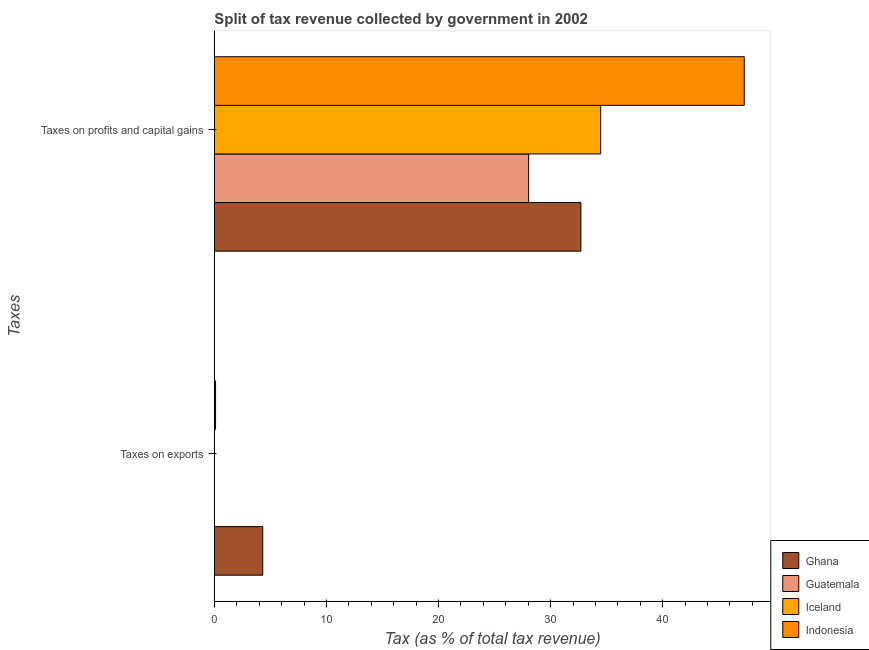How many different coloured bars are there?
Ensure brevity in your answer.  4. How many groups of bars are there?
Your answer should be very brief. 2. Are the number of bars per tick equal to the number of legend labels?
Provide a short and direct response. Yes. What is the label of the 2nd group of bars from the top?
Ensure brevity in your answer.  Taxes on exports. What is the percentage of revenue obtained from taxes on exports in Guatemala?
Give a very brief answer. 0.01. Across all countries, what is the maximum percentage of revenue obtained from taxes on profits and capital gains?
Your answer should be very brief. 47.28. Across all countries, what is the minimum percentage of revenue obtained from taxes on exports?
Your response must be concise. 0. In which country was the percentage of revenue obtained from taxes on exports maximum?
Offer a terse response. Ghana. In which country was the percentage of revenue obtained from taxes on profits and capital gains minimum?
Provide a succinct answer. Guatemala. What is the total percentage of revenue obtained from taxes on profits and capital gains in the graph?
Offer a very short reply. 142.5. What is the difference between the percentage of revenue obtained from taxes on exports in Ghana and that in Guatemala?
Ensure brevity in your answer.  4.31. What is the difference between the percentage of revenue obtained from taxes on profits and capital gains in Ghana and the percentage of revenue obtained from taxes on exports in Indonesia?
Provide a short and direct response. 32.6. What is the average percentage of revenue obtained from taxes on profits and capital gains per country?
Provide a succinct answer. 35.62. What is the difference between the percentage of revenue obtained from taxes on exports and percentage of revenue obtained from taxes on profits and capital gains in Guatemala?
Keep it short and to the point. -28.04. In how many countries, is the percentage of revenue obtained from taxes on profits and capital gains greater than 10 %?
Provide a short and direct response. 4. What is the ratio of the percentage of revenue obtained from taxes on exports in Indonesia to that in Guatemala?
Your response must be concise. 17.39. Is the percentage of revenue obtained from taxes on profits and capital gains in Iceland less than that in Guatemala?
Your response must be concise. No. In how many countries, is the percentage of revenue obtained from taxes on exports greater than the average percentage of revenue obtained from taxes on exports taken over all countries?
Provide a short and direct response. 1. What does the 2nd bar from the bottom in Taxes on exports represents?
Make the answer very short. Guatemala. How many bars are there?
Provide a succinct answer. 8. How many countries are there in the graph?
Your answer should be very brief. 4. Are the values on the major ticks of X-axis written in scientific E-notation?
Offer a terse response. No. How many legend labels are there?
Give a very brief answer. 4. How are the legend labels stacked?
Your answer should be compact. Vertical. What is the title of the graph?
Keep it short and to the point. Split of tax revenue collected by government in 2002. Does "China" appear as one of the legend labels in the graph?
Keep it short and to the point. No. What is the label or title of the X-axis?
Ensure brevity in your answer.  Tax (as % of total tax revenue). What is the label or title of the Y-axis?
Give a very brief answer. Taxes. What is the Tax (as % of total tax revenue) in Ghana in Taxes on exports?
Ensure brevity in your answer.  4.32. What is the Tax (as % of total tax revenue) of Guatemala in Taxes on exports?
Provide a succinct answer. 0.01. What is the Tax (as % of total tax revenue) in Iceland in Taxes on exports?
Ensure brevity in your answer.  0. What is the Tax (as % of total tax revenue) in Indonesia in Taxes on exports?
Your answer should be compact. 0.11. What is the Tax (as % of total tax revenue) of Ghana in Taxes on profits and capital gains?
Give a very brief answer. 32.7. What is the Tax (as % of total tax revenue) of Guatemala in Taxes on profits and capital gains?
Ensure brevity in your answer.  28.04. What is the Tax (as % of total tax revenue) in Iceland in Taxes on profits and capital gains?
Offer a very short reply. 34.47. What is the Tax (as % of total tax revenue) of Indonesia in Taxes on profits and capital gains?
Make the answer very short. 47.28. Across all Taxes, what is the maximum Tax (as % of total tax revenue) of Ghana?
Make the answer very short. 32.7. Across all Taxes, what is the maximum Tax (as % of total tax revenue) of Guatemala?
Your answer should be very brief. 28.04. Across all Taxes, what is the maximum Tax (as % of total tax revenue) of Iceland?
Provide a succinct answer. 34.47. Across all Taxes, what is the maximum Tax (as % of total tax revenue) in Indonesia?
Your answer should be compact. 47.28. Across all Taxes, what is the minimum Tax (as % of total tax revenue) in Ghana?
Provide a short and direct response. 4.32. Across all Taxes, what is the minimum Tax (as % of total tax revenue) of Guatemala?
Provide a short and direct response. 0.01. Across all Taxes, what is the minimum Tax (as % of total tax revenue) in Iceland?
Make the answer very short. 0. Across all Taxes, what is the minimum Tax (as % of total tax revenue) in Indonesia?
Offer a very short reply. 0.11. What is the total Tax (as % of total tax revenue) in Ghana in the graph?
Keep it short and to the point. 37.02. What is the total Tax (as % of total tax revenue) in Guatemala in the graph?
Offer a terse response. 28.05. What is the total Tax (as % of total tax revenue) in Iceland in the graph?
Provide a short and direct response. 34.47. What is the total Tax (as % of total tax revenue) in Indonesia in the graph?
Your answer should be very brief. 47.39. What is the difference between the Tax (as % of total tax revenue) of Ghana in Taxes on exports and that in Taxes on profits and capital gains?
Your response must be concise. -28.39. What is the difference between the Tax (as % of total tax revenue) of Guatemala in Taxes on exports and that in Taxes on profits and capital gains?
Give a very brief answer. -28.04. What is the difference between the Tax (as % of total tax revenue) in Iceland in Taxes on exports and that in Taxes on profits and capital gains?
Give a very brief answer. -34.47. What is the difference between the Tax (as % of total tax revenue) of Indonesia in Taxes on exports and that in Taxes on profits and capital gains?
Give a very brief answer. -47.17. What is the difference between the Tax (as % of total tax revenue) of Ghana in Taxes on exports and the Tax (as % of total tax revenue) of Guatemala in Taxes on profits and capital gains?
Offer a terse response. -23.73. What is the difference between the Tax (as % of total tax revenue) in Ghana in Taxes on exports and the Tax (as % of total tax revenue) in Iceland in Taxes on profits and capital gains?
Make the answer very short. -30.15. What is the difference between the Tax (as % of total tax revenue) of Ghana in Taxes on exports and the Tax (as % of total tax revenue) of Indonesia in Taxes on profits and capital gains?
Give a very brief answer. -42.96. What is the difference between the Tax (as % of total tax revenue) of Guatemala in Taxes on exports and the Tax (as % of total tax revenue) of Iceland in Taxes on profits and capital gains?
Ensure brevity in your answer.  -34.46. What is the difference between the Tax (as % of total tax revenue) of Guatemala in Taxes on exports and the Tax (as % of total tax revenue) of Indonesia in Taxes on profits and capital gains?
Ensure brevity in your answer.  -47.27. What is the difference between the Tax (as % of total tax revenue) in Iceland in Taxes on exports and the Tax (as % of total tax revenue) in Indonesia in Taxes on profits and capital gains?
Offer a very short reply. -47.28. What is the average Tax (as % of total tax revenue) in Ghana per Taxes?
Give a very brief answer. 18.51. What is the average Tax (as % of total tax revenue) of Guatemala per Taxes?
Keep it short and to the point. 14.02. What is the average Tax (as % of total tax revenue) of Iceland per Taxes?
Keep it short and to the point. 17.24. What is the average Tax (as % of total tax revenue) in Indonesia per Taxes?
Provide a succinct answer. 23.69. What is the difference between the Tax (as % of total tax revenue) of Ghana and Tax (as % of total tax revenue) of Guatemala in Taxes on exports?
Your answer should be compact. 4.31. What is the difference between the Tax (as % of total tax revenue) in Ghana and Tax (as % of total tax revenue) in Iceland in Taxes on exports?
Give a very brief answer. 4.32. What is the difference between the Tax (as % of total tax revenue) of Ghana and Tax (as % of total tax revenue) of Indonesia in Taxes on exports?
Ensure brevity in your answer.  4.21. What is the difference between the Tax (as % of total tax revenue) in Guatemala and Tax (as % of total tax revenue) in Iceland in Taxes on exports?
Offer a terse response. 0.01. What is the difference between the Tax (as % of total tax revenue) of Guatemala and Tax (as % of total tax revenue) of Indonesia in Taxes on exports?
Keep it short and to the point. -0.1. What is the difference between the Tax (as % of total tax revenue) of Iceland and Tax (as % of total tax revenue) of Indonesia in Taxes on exports?
Offer a very short reply. -0.11. What is the difference between the Tax (as % of total tax revenue) in Ghana and Tax (as % of total tax revenue) in Guatemala in Taxes on profits and capital gains?
Make the answer very short. 4.66. What is the difference between the Tax (as % of total tax revenue) of Ghana and Tax (as % of total tax revenue) of Iceland in Taxes on profits and capital gains?
Ensure brevity in your answer.  -1.77. What is the difference between the Tax (as % of total tax revenue) in Ghana and Tax (as % of total tax revenue) in Indonesia in Taxes on profits and capital gains?
Ensure brevity in your answer.  -14.58. What is the difference between the Tax (as % of total tax revenue) in Guatemala and Tax (as % of total tax revenue) in Iceland in Taxes on profits and capital gains?
Your answer should be very brief. -6.43. What is the difference between the Tax (as % of total tax revenue) in Guatemala and Tax (as % of total tax revenue) in Indonesia in Taxes on profits and capital gains?
Your answer should be very brief. -19.24. What is the difference between the Tax (as % of total tax revenue) of Iceland and Tax (as % of total tax revenue) of Indonesia in Taxes on profits and capital gains?
Your response must be concise. -12.81. What is the ratio of the Tax (as % of total tax revenue) in Ghana in Taxes on exports to that in Taxes on profits and capital gains?
Provide a short and direct response. 0.13. What is the ratio of the Tax (as % of total tax revenue) of Guatemala in Taxes on exports to that in Taxes on profits and capital gains?
Offer a terse response. 0. What is the ratio of the Tax (as % of total tax revenue) in Iceland in Taxes on exports to that in Taxes on profits and capital gains?
Make the answer very short. 0. What is the ratio of the Tax (as % of total tax revenue) in Indonesia in Taxes on exports to that in Taxes on profits and capital gains?
Offer a very short reply. 0. What is the difference between the highest and the second highest Tax (as % of total tax revenue) in Ghana?
Ensure brevity in your answer.  28.39. What is the difference between the highest and the second highest Tax (as % of total tax revenue) in Guatemala?
Provide a short and direct response. 28.04. What is the difference between the highest and the second highest Tax (as % of total tax revenue) of Iceland?
Provide a short and direct response. 34.47. What is the difference between the highest and the second highest Tax (as % of total tax revenue) in Indonesia?
Your response must be concise. 47.17. What is the difference between the highest and the lowest Tax (as % of total tax revenue) in Ghana?
Make the answer very short. 28.39. What is the difference between the highest and the lowest Tax (as % of total tax revenue) of Guatemala?
Keep it short and to the point. 28.04. What is the difference between the highest and the lowest Tax (as % of total tax revenue) in Iceland?
Your answer should be very brief. 34.47. What is the difference between the highest and the lowest Tax (as % of total tax revenue) of Indonesia?
Offer a very short reply. 47.17. 